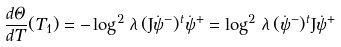Convert formula to latex. <formula><loc_0><loc_0><loc_500><loc_500>\frac { d \Theta } { d T } ( T _ { 1 } ) = - \log ^ { 2 } \, \lambda \, ( { \mathrm J } \dot { \psi } ^ { - } ) ^ { t } \dot { \psi } ^ { + } = \log ^ { 2 } \, \lambda \, ( \dot { \psi } ^ { - } ) ^ { t } { \mathrm J } \dot { \psi } ^ { + }</formula> 